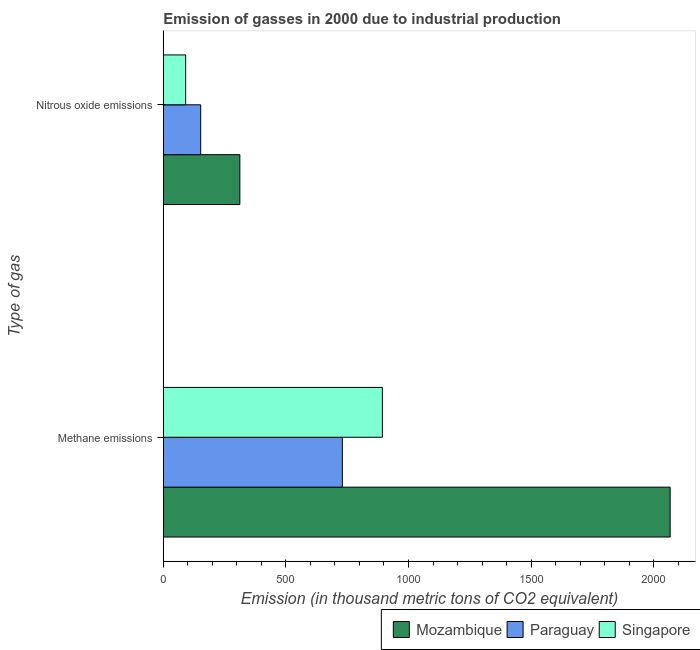How many groups of bars are there?
Ensure brevity in your answer.  2. Are the number of bars per tick equal to the number of legend labels?
Keep it short and to the point. Yes. What is the label of the 1st group of bars from the top?
Make the answer very short. Nitrous oxide emissions. What is the amount of methane emissions in Mozambique?
Offer a terse response. 2067.1. Across all countries, what is the maximum amount of methane emissions?
Provide a short and direct response. 2067.1. Across all countries, what is the minimum amount of nitrous oxide emissions?
Your response must be concise. 91.1. In which country was the amount of methane emissions maximum?
Your answer should be very brief. Mozambique. In which country was the amount of nitrous oxide emissions minimum?
Offer a very short reply. Singapore. What is the total amount of methane emissions in the graph?
Provide a short and direct response. 3690.8. What is the difference between the amount of methane emissions in Mozambique and that in Paraguay?
Ensure brevity in your answer.  1336.9. What is the difference between the amount of nitrous oxide emissions in Mozambique and the amount of methane emissions in Singapore?
Keep it short and to the point. -581.3. What is the average amount of nitrous oxide emissions per country?
Provide a short and direct response. 185.27. What is the difference between the amount of methane emissions and amount of nitrous oxide emissions in Paraguay?
Ensure brevity in your answer.  577.7. In how many countries, is the amount of methane emissions greater than 300 thousand metric tons?
Provide a succinct answer. 3. What is the ratio of the amount of methane emissions in Paraguay to that in Singapore?
Ensure brevity in your answer.  0.82. What does the 3rd bar from the top in Nitrous oxide emissions represents?
Ensure brevity in your answer.  Mozambique. What does the 3rd bar from the bottom in Nitrous oxide emissions represents?
Offer a very short reply. Singapore. Are all the bars in the graph horizontal?
Your answer should be very brief. Yes. Does the graph contain any zero values?
Your response must be concise. No. Does the graph contain grids?
Make the answer very short. No. How many legend labels are there?
Make the answer very short. 3. How are the legend labels stacked?
Keep it short and to the point. Horizontal. What is the title of the graph?
Make the answer very short. Emission of gasses in 2000 due to industrial production. What is the label or title of the X-axis?
Provide a succinct answer. Emission (in thousand metric tons of CO2 equivalent). What is the label or title of the Y-axis?
Ensure brevity in your answer.  Type of gas. What is the Emission (in thousand metric tons of CO2 equivalent) in Mozambique in Methane emissions?
Offer a terse response. 2067.1. What is the Emission (in thousand metric tons of CO2 equivalent) in Paraguay in Methane emissions?
Your answer should be very brief. 730.2. What is the Emission (in thousand metric tons of CO2 equivalent) in Singapore in Methane emissions?
Your answer should be very brief. 893.5. What is the Emission (in thousand metric tons of CO2 equivalent) in Mozambique in Nitrous oxide emissions?
Offer a terse response. 312.2. What is the Emission (in thousand metric tons of CO2 equivalent) of Paraguay in Nitrous oxide emissions?
Provide a short and direct response. 152.5. What is the Emission (in thousand metric tons of CO2 equivalent) in Singapore in Nitrous oxide emissions?
Your response must be concise. 91.1. Across all Type of gas, what is the maximum Emission (in thousand metric tons of CO2 equivalent) of Mozambique?
Provide a short and direct response. 2067.1. Across all Type of gas, what is the maximum Emission (in thousand metric tons of CO2 equivalent) of Paraguay?
Ensure brevity in your answer.  730.2. Across all Type of gas, what is the maximum Emission (in thousand metric tons of CO2 equivalent) in Singapore?
Your response must be concise. 893.5. Across all Type of gas, what is the minimum Emission (in thousand metric tons of CO2 equivalent) of Mozambique?
Offer a terse response. 312.2. Across all Type of gas, what is the minimum Emission (in thousand metric tons of CO2 equivalent) in Paraguay?
Keep it short and to the point. 152.5. Across all Type of gas, what is the minimum Emission (in thousand metric tons of CO2 equivalent) in Singapore?
Your response must be concise. 91.1. What is the total Emission (in thousand metric tons of CO2 equivalent) in Mozambique in the graph?
Ensure brevity in your answer.  2379.3. What is the total Emission (in thousand metric tons of CO2 equivalent) of Paraguay in the graph?
Offer a terse response. 882.7. What is the total Emission (in thousand metric tons of CO2 equivalent) in Singapore in the graph?
Your response must be concise. 984.6. What is the difference between the Emission (in thousand metric tons of CO2 equivalent) of Mozambique in Methane emissions and that in Nitrous oxide emissions?
Offer a very short reply. 1754.9. What is the difference between the Emission (in thousand metric tons of CO2 equivalent) of Paraguay in Methane emissions and that in Nitrous oxide emissions?
Your answer should be compact. 577.7. What is the difference between the Emission (in thousand metric tons of CO2 equivalent) of Singapore in Methane emissions and that in Nitrous oxide emissions?
Offer a very short reply. 802.4. What is the difference between the Emission (in thousand metric tons of CO2 equivalent) in Mozambique in Methane emissions and the Emission (in thousand metric tons of CO2 equivalent) in Paraguay in Nitrous oxide emissions?
Make the answer very short. 1914.6. What is the difference between the Emission (in thousand metric tons of CO2 equivalent) of Mozambique in Methane emissions and the Emission (in thousand metric tons of CO2 equivalent) of Singapore in Nitrous oxide emissions?
Offer a very short reply. 1976. What is the difference between the Emission (in thousand metric tons of CO2 equivalent) in Paraguay in Methane emissions and the Emission (in thousand metric tons of CO2 equivalent) in Singapore in Nitrous oxide emissions?
Offer a very short reply. 639.1. What is the average Emission (in thousand metric tons of CO2 equivalent) in Mozambique per Type of gas?
Offer a terse response. 1189.65. What is the average Emission (in thousand metric tons of CO2 equivalent) in Paraguay per Type of gas?
Your answer should be very brief. 441.35. What is the average Emission (in thousand metric tons of CO2 equivalent) of Singapore per Type of gas?
Keep it short and to the point. 492.3. What is the difference between the Emission (in thousand metric tons of CO2 equivalent) in Mozambique and Emission (in thousand metric tons of CO2 equivalent) in Paraguay in Methane emissions?
Make the answer very short. 1336.9. What is the difference between the Emission (in thousand metric tons of CO2 equivalent) in Mozambique and Emission (in thousand metric tons of CO2 equivalent) in Singapore in Methane emissions?
Provide a short and direct response. 1173.6. What is the difference between the Emission (in thousand metric tons of CO2 equivalent) in Paraguay and Emission (in thousand metric tons of CO2 equivalent) in Singapore in Methane emissions?
Offer a terse response. -163.3. What is the difference between the Emission (in thousand metric tons of CO2 equivalent) in Mozambique and Emission (in thousand metric tons of CO2 equivalent) in Paraguay in Nitrous oxide emissions?
Offer a terse response. 159.7. What is the difference between the Emission (in thousand metric tons of CO2 equivalent) of Mozambique and Emission (in thousand metric tons of CO2 equivalent) of Singapore in Nitrous oxide emissions?
Make the answer very short. 221.1. What is the difference between the Emission (in thousand metric tons of CO2 equivalent) of Paraguay and Emission (in thousand metric tons of CO2 equivalent) of Singapore in Nitrous oxide emissions?
Your response must be concise. 61.4. What is the ratio of the Emission (in thousand metric tons of CO2 equivalent) of Mozambique in Methane emissions to that in Nitrous oxide emissions?
Make the answer very short. 6.62. What is the ratio of the Emission (in thousand metric tons of CO2 equivalent) of Paraguay in Methane emissions to that in Nitrous oxide emissions?
Your answer should be very brief. 4.79. What is the ratio of the Emission (in thousand metric tons of CO2 equivalent) of Singapore in Methane emissions to that in Nitrous oxide emissions?
Give a very brief answer. 9.81. What is the difference between the highest and the second highest Emission (in thousand metric tons of CO2 equivalent) of Mozambique?
Offer a terse response. 1754.9. What is the difference between the highest and the second highest Emission (in thousand metric tons of CO2 equivalent) of Paraguay?
Give a very brief answer. 577.7. What is the difference between the highest and the second highest Emission (in thousand metric tons of CO2 equivalent) of Singapore?
Make the answer very short. 802.4. What is the difference between the highest and the lowest Emission (in thousand metric tons of CO2 equivalent) of Mozambique?
Your answer should be very brief. 1754.9. What is the difference between the highest and the lowest Emission (in thousand metric tons of CO2 equivalent) of Paraguay?
Your response must be concise. 577.7. What is the difference between the highest and the lowest Emission (in thousand metric tons of CO2 equivalent) of Singapore?
Give a very brief answer. 802.4. 